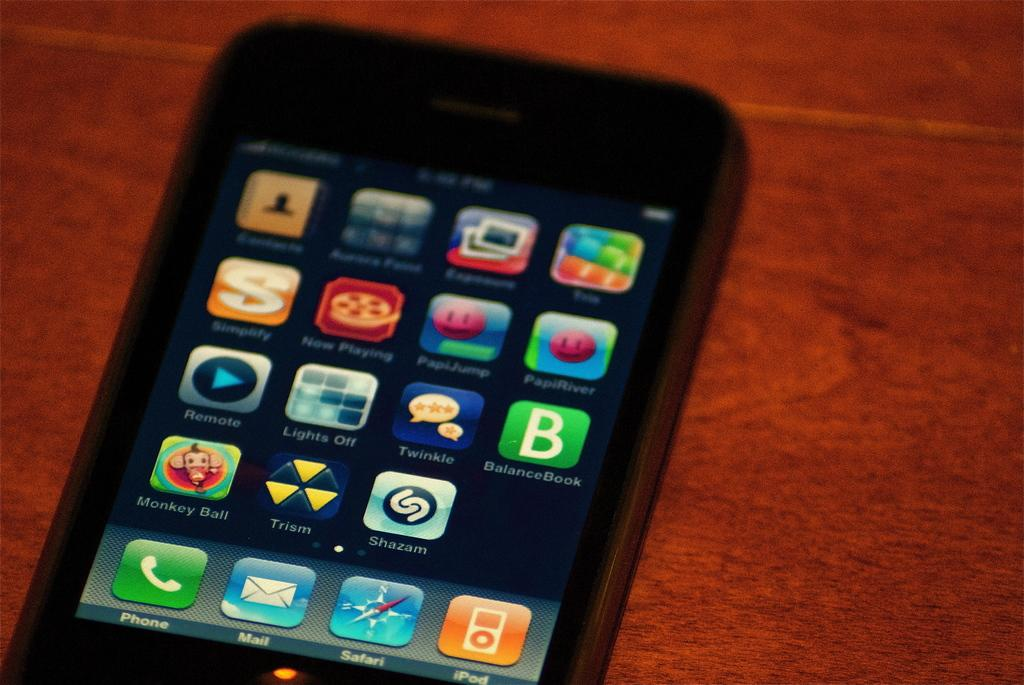<image>
Share a concise interpretation of the image provided. a cell phone display with icons for PHONE and MAIL 